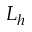<formula> <loc_0><loc_0><loc_500><loc_500>L _ { h }</formula> 